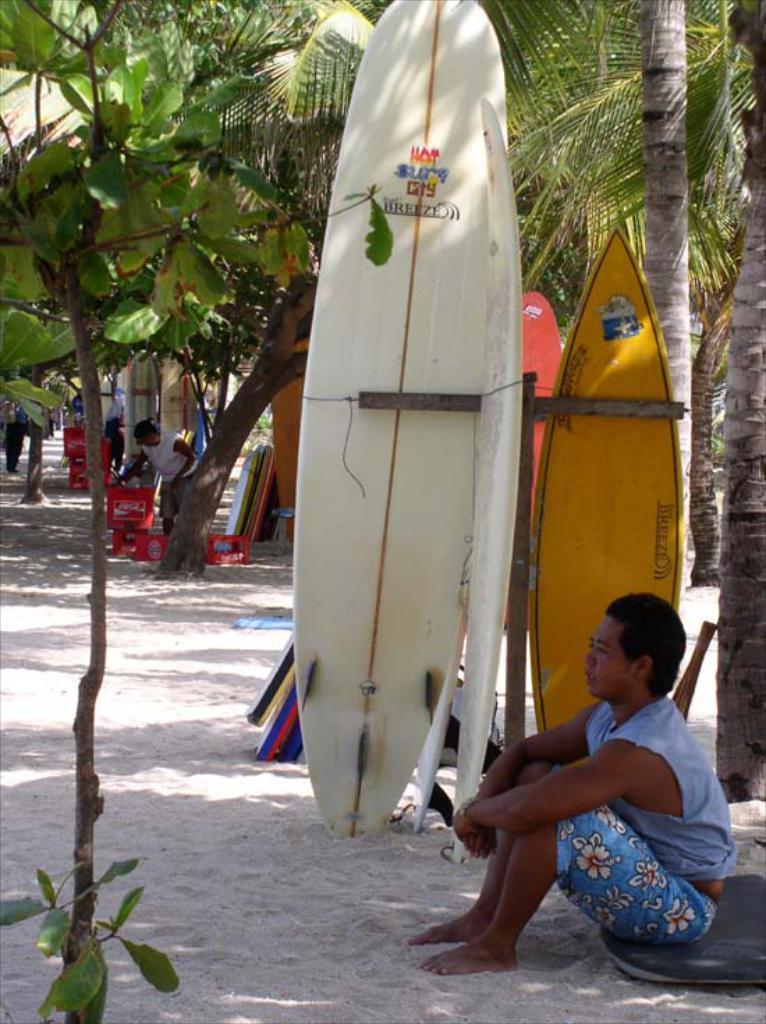Could you give a brief overview of what you see in this image? In the image we can see a person sitting and wearing clothes. This is a sand, trees, water boards and the container. There are even other people. 